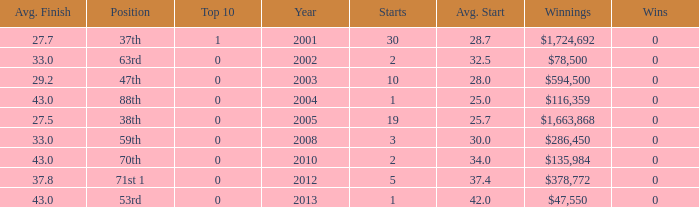What is the average top 10 score for 2 starts, winnings of $135,984 and an average finish more than 43? None. 